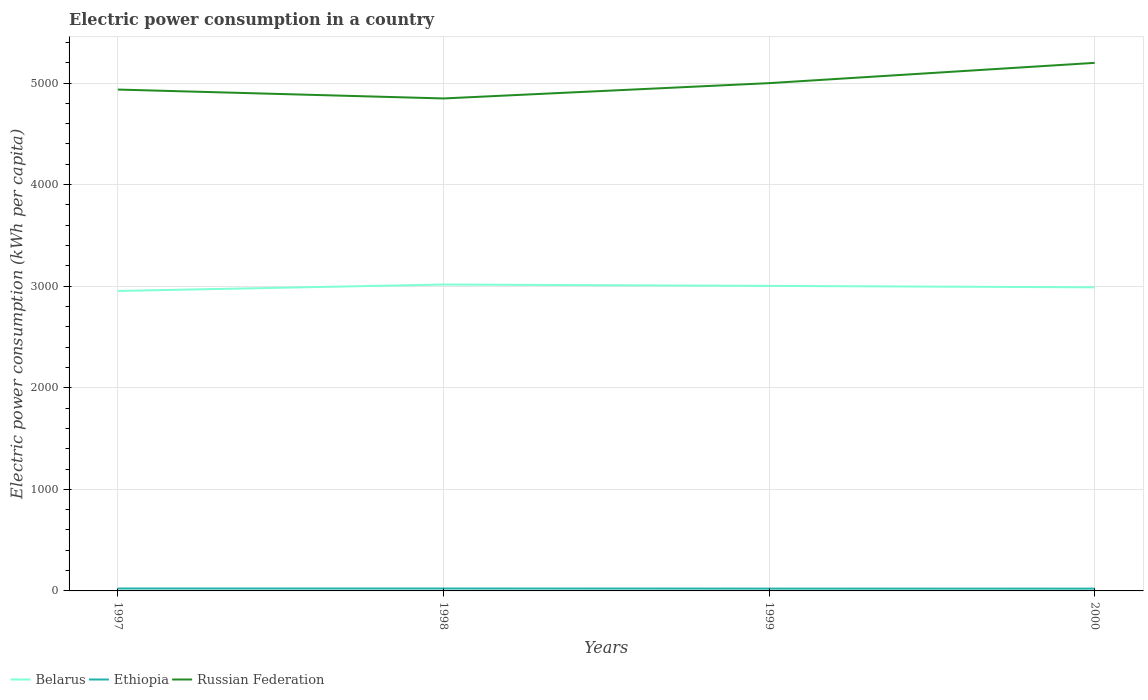How many different coloured lines are there?
Your answer should be compact. 3. Across all years, what is the maximum electric power consumption in in Ethiopia?
Provide a succinct answer. 22.68. In which year was the electric power consumption in in Russian Federation maximum?
Give a very brief answer. 1998. What is the total electric power consumption in in Ethiopia in the graph?
Your answer should be compact. 1.18. What is the difference between the highest and the second highest electric power consumption in in Ethiopia?
Keep it short and to the point. 1.18. What is the difference between the highest and the lowest electric power consumption in in Ethiopia?
Give a very brief answer. 2. Are the values on the major ticks of Y-axis written in scientific E-notation?
Offer a terse response. No. Does the graph contain grids?
Your answer should be very brief. Yes. Where does the legend appear in the graph?
Offer a very short reply. Bottom left. How are the legend labels stacked?
Ensure brevity in your answer.  Horizontal. What is the title of the graph?
Your answer should be very brief. Electric power consumption in a country. What is the label or title of the Y-axis?
Make the answer very short. Electric power consumption (kWh per capita). What is the Electric power consumption (kWh per capita) of Belarus in 1997?
Your response must be concise. 2953.05. What is the Electric power consumption (kWh per capita) of Ethiopia in 1997?
Offer a very short reply. 23.86. What is the Electric power consumption (kWh per capita) of Russian Federation in 1997?
Offer a very short reply. 4935.62. What is the Electric power consumption (kWh per capita) of Belarus in 1998?
Make the answer very short. 3016.29. What is the Electric power consumption (kWh per capita) of Ethiopia in 1998?
Offer a very short reply. 23.73. What is the Electric power consumption (kWh per capita) of Russian Federation in 1998?
Provide a short and direct response. 4848.03. What is the Electric power consumption (kWh per capita) in Belarus in 1999?
Your response must be concise. 3002.89. What is the Electric power consumption (kWh per capita) of Ethiopia in 1999?
Your response must be concise. 22.93. What is the Electric power consumption (kWh per capita) in Russian Federation in 1999?
Your response must be concise. 4998.84. What is the Electric power consumption (kWh per capita) of Belarus in 2000?
Your answer should be very brief. 2988.71. What is the Electric power consumption (kWh per capita) of Ethiopia in 2000?
Your answer should be very brief. 22.68. What is the Electric power consumption (kWh per capita) of Russian Federation in 2000?
Offer a very short reply. 5198.42. Across all years, what is the maximum Electric power consumption (kWh per capita) in Belarus?
Keep it short and to the point. 3016.29. Across all years, what is the maximum Electric power consumption (kWh per capita) of Ethiopia?
Offer a very short reply. 23.86. Across all years, what is the maximum Electric power consumption (kWh per capita) of Russian Federation?
Make the answer very short. 5198.42. Across all years, what is the minimum Electric power consumption (kWh per capita) of Belarus?
Your answer should be very brief. 2953.05. Across all years, what is the minimum Electric power consumption (kWh per capita) in Ethiopia?
Make the answer very short. 22.68. Across all years, what is the minimum Electric power consumption (kWh per capita) of Russian Federation?
Keep it short and to the point. 4848.03. What is the total Electric power consumption (kWh per capita) of Belarus in the graph?
Ensure brevity in your answer.  1.20e+04. What is the total Electric power consumption (kWh per capita) of Ethiopia in the graph?
Provide a succinct answer. 93.2. What is the total Electric power consumption (kWh per capita) in Russian Federation in the graph?
Offer a terse response. 2.00e+04. What is the difference between the Electric power consumption (kWh per capita) in Belarus in 1997 and that in 1998?
Keep it short and to the point. -63.24. What is the difference between the Electric power consumption (kWh per capita) of Ethiopia in 1997 and that in 1998?
Make the answer very short. 0.13. What is the difference between the Electric power consumption (kWh per capita) of Russian Federation in 1997 and that in 1998?
Offer a terse response. 87.59. What is the difference between the Electric power consumption (kWh per capita) of Belarus in 1997 and that in 1999?
Ensure brevity in your answer.  -49.84. What is the difference between the Electric power consumption (kWh per capita) in Ethiopia in 1997 and that in 1999?
Offer a very short reply. 0.93. What is the difference between the Electric power consumption (kWh per capita) of Russian Federation in 1997 and that in 1999?
Give a very brief answer. -63.22. What is the difference between the Electric power consumption (kWh per capita) of Belarus in 1997 and that in 2000?
Offer a terse response. -35.66. What is the difference between the Electric power consumption (kWh per capita) in Ethiopia in 1997 and that in 2000?
Offer a very short reply. 1.18. What is the difference between the Electric power consumption (kWh per capita) in Russian Federation in 1997 and that in 2000?
Make the answer very short. -262.8. What is the difference between the Electric power consumption (kWh per capita) of Belarus in 1998 and that in 1999?
Offer a very short reply. 13.4. What is the difference between the Electric power consumption (kWh per capita) in Ethiopia in 1998 and that in 1999?
Your answer should be very brief. 0.8. What is the difference between the Electric power consumption (kWh per capita) in Russian Federation in 1998 and that in 1999?
Provide a succinct answer. -150.81. What is the difference between the Electric power consumption (kWh per capita) of Belarus in 1998 and that in 2000?
Your answer should be very brief. 27.58. What is the difference between the Electric power consumption (kWh per capita) in Ethiopia in 1998 and that in 2000?
Your answer should be very brief. 1.05. What is the difference between the Electric power consumption (kWh per capita) in Russian Federation in 1998 and that in 2000?
Your answer should be very brief. -350.39. What is the difference between the Electric power consumption (kWh per capita) in Belarus in 1999 and that in 2000?
Provide a short and direct response. 14.18. What is the difference between the Electric power consumption (kWh per capita) in Ethiopia in 1999 and that in 2000?
Give a very brief answer. 0.25. What is the difference between the Electric power consumption (kWh per capita) of Russian Federation in 1999 and that in 2000?
Your answer should be very brief. -199.58. What is the difference between the Electric power consumption (kWh per capita) in Belarus in 1997 and the Electric power consumption (kWh per capita) in Ethiopia in 1998?
Your answer should be compact. 2929.32. What is the difference between the Electric power consumption (kWh per capita) of Belarus in 1997 and the Electric power consumption (kWh per capita) of Russian Federation in 1998?
Keep it short and to the point. -1894.98. What is the difference between the Electric power consumption (kWh per capita) of Ethiopia in 1997 and the Electric power consumption (kWh per capita) of Russian Federation in 1998?
Ensure brevity in your answer.  -4824.17. What is the difference between the Electric power consumption (kWh per capita) of Belarus in 1997 and the Electric power consumption (kWh per capita) of Ethiopia in 1999?
Keep it short and to the point. 2930.12. What is the difference between the Electric power consumption (kWh per capita) in Belarus in 1997 and the Electric power consumption (kWh per capita) in Russian Federation in 1999?
Your answer should be compact. -2045.79. What is the difference between the Electric power consumption (kWh per capita) in Ethiopia in 1997 and the Electric power consumption (kWh per capita) in Russian Federation in 1999?
Your answer should be compact. -4974.98. What is the difference between the Electric power consumption (kWh per capita) of Belarus in 1997 and the Electric power consumption (kWh per capita) of Ethiopia in 2000?
Provide a short and direct response. 2930.37. What is the difference between the Electric power consumption (kWh per capita) of Belarus in 1997 and the Electric power consumption (kWh per capita) of Russian Federation in 2000?
Offer a very short reply. -2245.37. What is the difference between the Electric power consumption (kWh per capita) of Ethiopia in 1997 and the Electric power consumption (kWh per capita) of Russian Federation in 2000?
Your response must be concise. -5174.56. What is the difference between the Electric power consumption (kWh per capita) in Belarus in 1998 and the Electric power consumption (kWh per capita) in Ethiopia in 1999?
Offer a very short reply. 2993.36. What is the difference between the Electric power consumption (kWh per capita) in Belarus in 1998 and the Electric power consumption (kWh per capita) in Russian Federation in 1999?
Your answer should be compact. -1982.55. What is the difference between the Electric power consumption (kWh per capita) of Ethiopia in 1998 and the Electric power consumption (kWh per capita) of Russian Federation in 1999?
Your answer should be very brief. -4975.11. What is the difference between the Electric power consumption (kWh per capita) of Belarus in 1998 and the Electric power consumption (kWh per capita) of Ethiopia in 2000?
Keep it short and to the point. 2993.61. What is the difference between the Electric power consumption (kWh per capita) of Belarus in 1998 and the Electric power consumption (kWh per capita) of Russian Federation in 2000?
Ensure brevity in your answer.  -2182.13. What is the difference between the Electric power consumption (kWh per capita) of Ethiopia in 1998 and the Electric power consumption (kWh per capita) of Russian Federation in 2000?
Provide a succinct answer. -5174.69. What is the difference between the Electric power consumption (kWh per capita) in Belarus in 1999 and the Electric power consumption (kWh per capita) in Ethiopia in 2000?
Ensure brevity in your answer.  2980.21. What is the difference between the Electric power consumption (kWh per capita) in Belarus in 1999 and the Electric power consumption (kWh per capita) in Russian Federation in 2000?
Make the answer very short. -2195.53. What is the difference between the Electric power consumption (kWh per capita) in Ethiopia in 1999 and the Electric power consumption (kWh per capita) in Russian Federation in 2000?
Give a very brief answer. -5175.49. What is the average Electric power consumption (kWh per capita) of Belarus per year?
Keep it short and to the point. 2990.23. What is the average Electric power consumption (kWh per capita) in Ethiopia per year?
Keep it short and to the point. 23.3. What is the average Electric power consumption (kWh per capita) in Russian Federation per year?
Give a very brief answer. 4995.23. In the year 1997, what is the difference between the Electric power consumption (kWh per capita) of Belarus and Electric power consumption (kWh per capita) of Ethiopia?
Offer a very short reply. 2929.19. In the year 1997, what is the difference between the Electric power consumption (kWh per capita) in Belarus and Electric power consumption (kWh per capita) in Russian Federation?
Provide a short and direct response. -1982.57. In the year 1997, what is the difference between the Electric power consumption (kWh per capita) of Ethiopia and Electric power consumption (kWh per capita) of Russian Federation?
Give a very brief answer. -4911.76. In the year 1998, what is the difference between the Electric power consumption (kWh per capita) of Belarus and Electric power consumption (kWh per capita) of Ethiopia?
Your answer should be compact. 2992.56. In the year 1998, what is the difference between the Electric power consumption (kWh per capita) of Belarus and Electric power consumption (kWh per capita) of Russian Federation?
Ensure brevity in your answer.  -1831.74. In the year 1998, what is the difference between the Electric power consumption (kWh per capita) in Ethiopia and Electric power consumption (kWh per capita) in Russian Federation?
Your response must be concise. -4824.3. In the year 1999, what is the difference between the Electric power consumption (kWh per capita) of Belarus and Electric power consumption (kWh per capita) of Ethiopia?
Your answer should be compact. 2979.96. In the year 1999, what is the difference between the Electric power consumption (kWh per capita) of Belarus and Electric power consumption (kWh per capita) of Russian Federation?
Your answer should be very brief. -1995.95. In the year 1999, what is the difference between the Electric power consumption (kWh per capita) in Ethiopia and Electric power consumption (kWh per capita) in Russian Federation?
Your answer should be compact. -4975.91. In the year 2000, what is the difference between the Electric power consumption (kWh per capita) in Belarus and Electric power consumption (kWh per capita) in Ethiopia?
Keep it short and to the point. 2966.02. In the year 2000, what is the difference between the Electric power consumption (kWh per capita) of Belarus and Electric power consumption (kWh per capita) of Russian Federation?
Ensure brevity in your answer.  -2209.71. In the year 2000, what is the difference between the Electric power consumption (kWh per capita) of Ethiopia and Electric power consumption (kWh per capita) of Russian Federation?
Give a very brief answer. -5175.74. What is the ratio of the Electric power consumption (kWh per capita) of Ethiopia in 1997 to that in 1998?
Provide a succinct answer. 1.01. What is the ratio of the Electric power consumption (kWh per capita) in Russian Federation in 1997 to that in 1998?
Offer a very short reply. 1.02. What is the ratio of the Electric power consumption (kWh per capita) in Belarus in 1997 to that in 1999?
Give a very brief answer. 0.98. What is the ratio of the Electric power consumption (kWh per capita) of Ethiopia in 1997 to that in 1999?
Offer a terse response. 1.04. What is the ratio of the Electric power consumption (kWh per capita) of Russian Federation in 1997 to that in 1999?
Give a very brief answer. 0.99. What is the ratio of the Electric power consumption (kWh per capita) in Belarus in 1997 to that in 2000?
Give a very brief answer. 0.99. What is the ratio of the Electric power consumption (kWh per capita) of Ethiopia in 1997 to that in 2000?
Ensure brevity in your answer.  1.05. What is the ratio of the Electric power consumption (kWh per capita) in Russian Federation in 1997 to that in 2000?
Offer a terse response. 0.95. What is the ratio of the Electric power consumption (kWh per capita) of Belarus in 1998 to that in 1999?
Provide a short and direct response. 1. What is the ratio of the Electric power consumption (kWh per capita) of Ethiopia in 1998 to that in 1999?
Your answer should be very brief. 1.03. What is the ratio of the Electric power consumption (kWh per capita) of Russian Federation in 1998 to that in 1999?
Offer a terse response. 0.97. What is the ratio of the Electric power consumption (kWh per capita) in Belarus in 1998 to that in 2000?
Give a very brief answer. 1.01. What is the ratio of the Electric power consumption (kWh per capita) of Ethiopia in 1998 to that in 2000?
Give a very brief answer. 1.05. What is the ratio of the Electric power consumption (kWh per capita) in Russian Federation in 1998 to that in 2000?
Offer a very short reply. 0.93. What is the ratio of the Electric power consumption (kWh per capita) of Belarus in 1999 to that in 2000?
Make the answer very short. 1. What is the ratio of the Electric power consumption (kWh per capita) of Ethiopia in 1999 to that in 2000?
Make the answer very short. 1.01. What is the ratio of the Electric power consumption (kWh per capita) of Russian Federation in 1999 to that in 2000?
Make the answer very short. 0.96. What is the difference between the highest and the second highest Electric power consumption (kWh per capita) of Belarus?
Give a very brief answer. 13.4. What is the difference between the highest and the second highest Electric power consumption (kWh per capita) in Ethiopia?
Provide a short and direct response. 0.13. What is the difference between the highest and the second highest Electric power consumption (kWh per capita) of Russian Federation?
Ensure brevity in your answer.  199.58. What is the difference between the highest and the lowest Electric power consumption (kWh per capita) in Belarus?
Offer a terse response. 63.24. What is the difference between the highest and the lowest Electric power consumption (kWh per capita) of Ethiopia?
Keep it short and to the point. 1.18. What is the difference between the highest and the lowest Electric power consumption (kWh per capita) in Russian Federation?
Your answer should be compact. 350.39. 